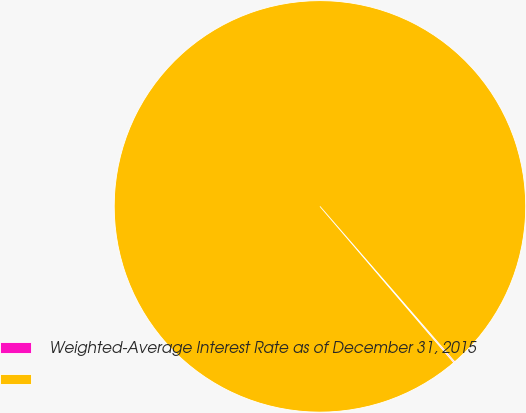<chart> <loc_0><loc_0><loc_500><loc_500><pie_chart><fcel>Weighted-Average Interest Rate as of December 31, 2015<fcel>Unnamed: 1<nl><fcel>0.1%<fcel>99.9%<nl></chart> 